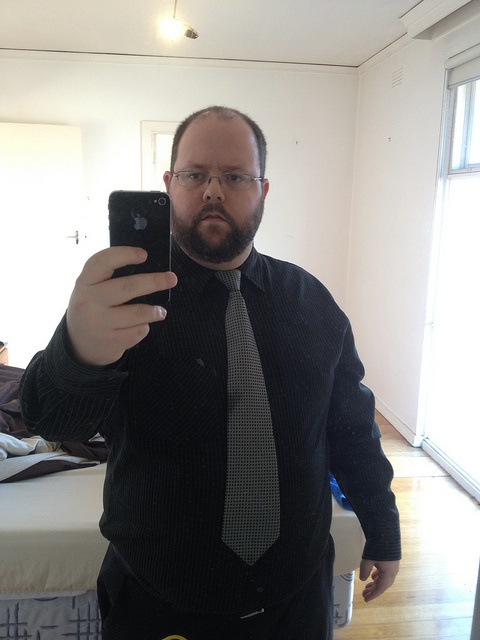Describe the objects in this image and their specific colors. I can see people in lightgray, black, and gray tones, bed in lightgray, gray, darkgray, and black tones, tie in lightgray, black, and gray tones, and cell phone in lightgray, black, and gray tones in this image. 